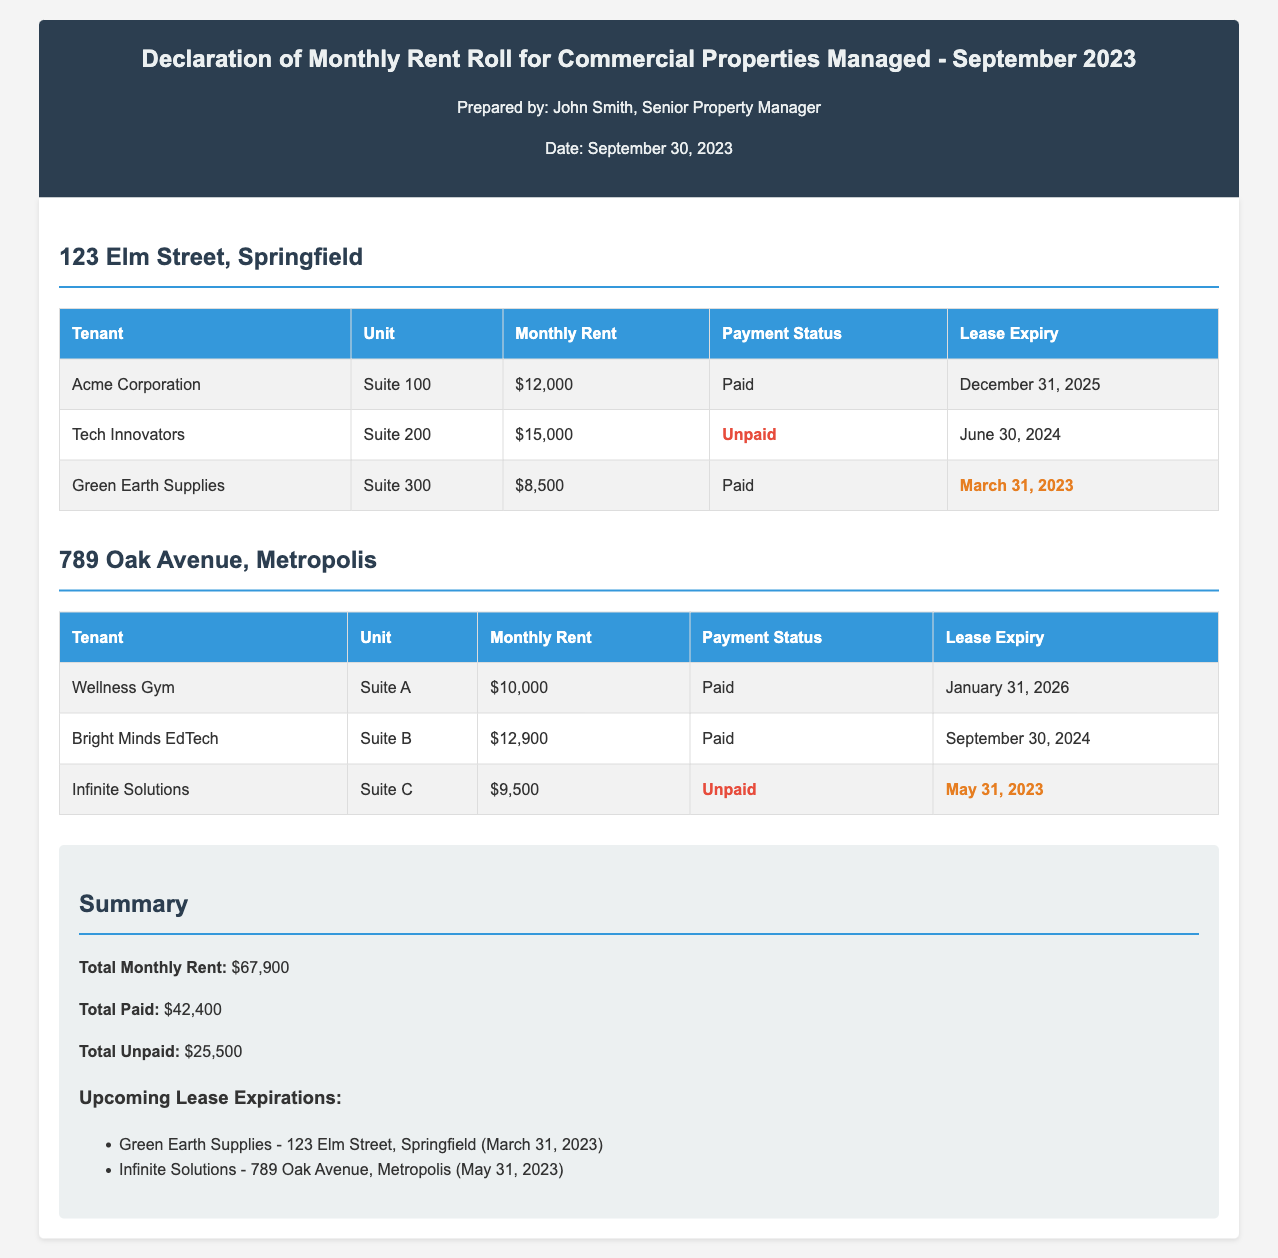What is the total monthly rent? The total monthly rent is calculated by summing all the monthly rents listed for the tenants, which equals $67,900.
Answer: $67,900 How many tenants have unpaid rent? The document lists specific tenants along with their payment status, showing two tenants with unpaid rent.
Answer: 2 Which tenant occupies Suite 200? The table specifically identifies the tenant for Suite 200 as "Tech Innovators."
Answer: Tech Innovators What is the lease expiry date for "Green Earth Supplies"? The lease expiry date for "Green Earth Supplies" is mentioned in the document as March 31, 2023.
Answer: March 31, 2023 What is the total amount of unpaid rent? The document summarizes unpaid rent amounts, totaling $25,500 for all unpaid tenants.
Answer: $25,500 Which tenant has the highest monthly rent? The document specifies that "Tech Innovators" has the highest monthly rent at $15,000.
Answer: Tech Innovators What color is used for unpaid payment status? The document indicates the color red for the unpaid payment status.
Answer: Red What property is listed in the first section? The first property listed is "123 Elm Street, Springfield."
Answer: 123 Elm Street, Springfield How many properties are reported in the document? The document outlines details for two properties, providing summaries for each.
Answer: 2 